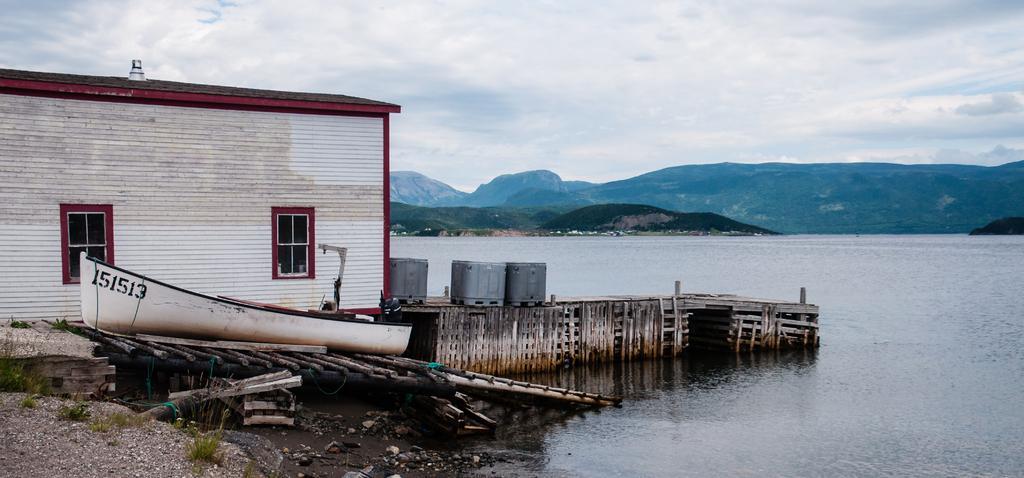Can you describe this image briefly? In this image I can see a white colour building, windows, a white colour boat, grass, water and few grey colour boxes. In the background I can see clouds and the sky. 